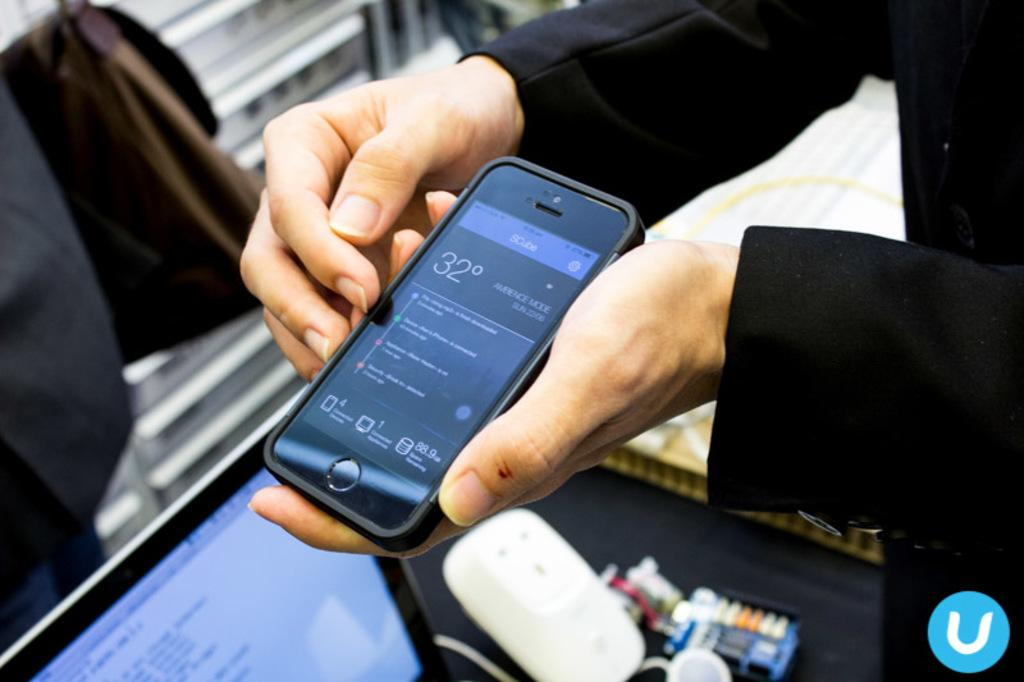<image>
Summarize the visual content of the image. A person holding a cellphone thats displaying the temperature being 32 degrees. 